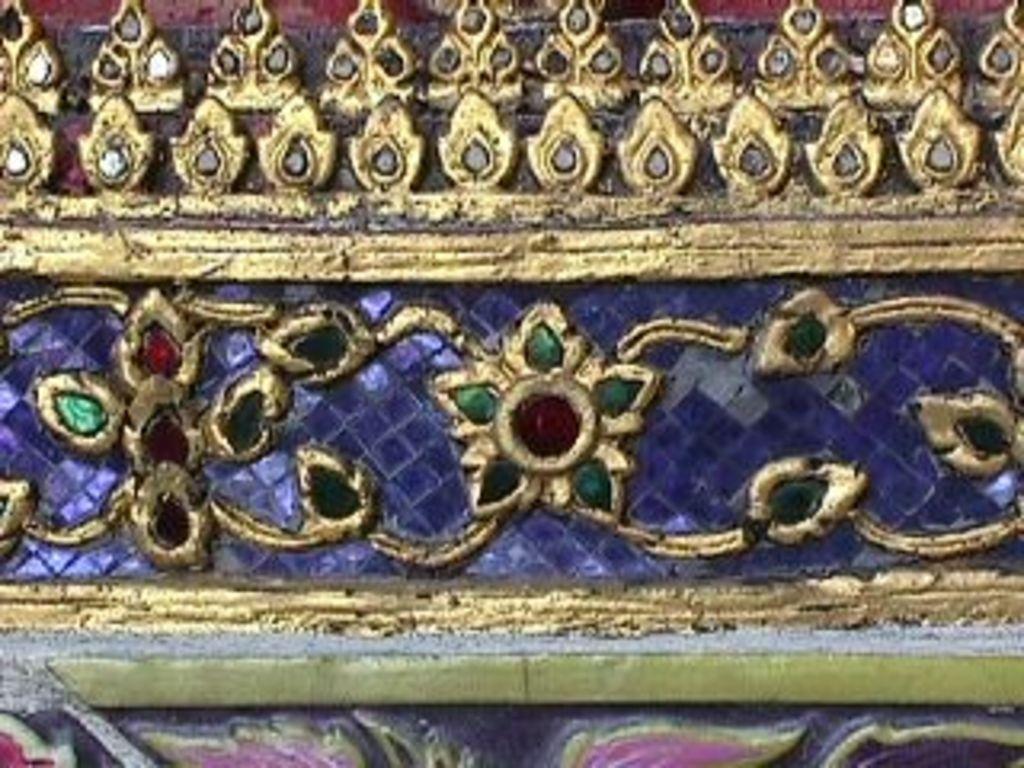Can you describe this image briefly? In this image, I can see the design of the flowers, which is carved on the stone. This design is gold, red and green in color. 